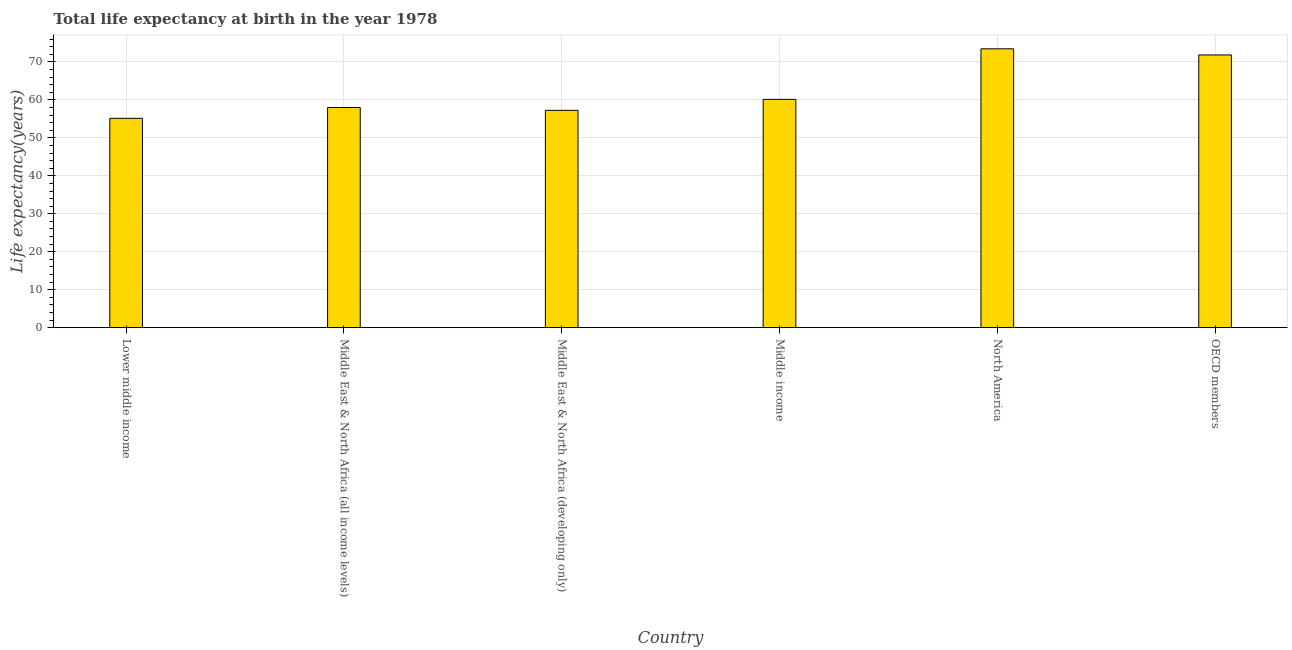Does the graph contain any zero values?
Ensure brevity in your answer.  No. Does the graph contain grids?
Your answer should be very brief. Yes. What is the title of the graph?
Offer a very short reply. Total life expectancy at birth in the year 1978. What is the label or title of the X-axis?
Make the answer very short. Country. What is the label or title of the Y-axis?
Provide a short and direct response. Life expectancy(years). What is the life expectancy at birth in OECD members?
Your answer should be very brief. 71.86. Across all countries, what is the maximum life expectancy at birth?
Make the answer very short. 73.47. Across all countries, what is the minimum life expectancy at birth?
Provide a short and direct response. 55.16. In which country was the life expectancy at birth minimum?
Keep it short and to the point. Lower middle income. What is the sum of the life expectancy at birth?
Give a very brief answer. 375.9. What is the difference between the life expectancy at birth in Lower middle income and Middle East & North Africa (all income levels)?
Your response must be concise. -2.85. What is the average life expectancy at birth per country?
Offer a terse response. 62.65. What is the median life expectancy at birth?
Offer a terse response. 59.08. What is the ratio of the life expectancy at birth in North America to that in OECD members?
Ensure brevity in your answer.  1.02. Is the life expectancy at birth in Middle East & North Africa (developing only) less than that in North America?
Give a very brief answer. Yes. Is the difference between the life expectancy at birth in Middle East & North Africa (developing only) and North America greater than the difference between any two countries?
Provide a succinct answer. No. What is the difference between the highest and the second highest life expectancy at birth?
Keep it short and to the point. 1.61. What is the difference between the highest and the lowest life expectancy at birth?
Make the answer very short. 18.31. How many bars are there?
Provide a succinct answer. 6. Are all the bars in the graph horizontal?
Provide a short and direct response. No. What is the difference between two consecutive major ticks on the Y-axis?
Offer a terse response. 10. Are the values on the major ticks of Y-axis written in scientific E-notation?
Your answer should be compact. No. What is the Life expectancy(years) of Lower middle income?
Your answer should be compact. 55.16. What is the Life expectancy(years) of Middle East & North Africa (all income levels)?
Offer a very short reply. 58. What is the Life expectancy(years) of Middle East & North Africa (developing only)?
Make the answer very short. 57.26. What is the Life expectancy(years) in Middle income?
Give a very brief answer. 60.15. What is the Life expectancy(years) of North America?
Provide a short and direct response. 73.47. What is the Life expectancy(years) in OECD members?
Make the answer very short. 71.86. What is the difference between the Life expectancy(years) in Lower middle income and Middle East & North Africa (all income levels)?
Give a very brief answer. -2.85. What is the difference between the Life expectancy(years) in Lower middle income and Middle East & North Africa (developing only)?
Provide a succinct answer. -2.1. What is the difference between the Life expectancy(years) in Lower middle income and Middle income?
Your answer should be compact. -5. What is the difference between the Life expectancy(years) in Lower middle income and North America?
Offer a very short reply. -18.31. What is the difference between the Life expectancy(years) in Lower middle income and OECD members?
Ensure brevity in your answer.  -16.7. What is the difference between the Life expectancy(years) in Middle East & North Africa (all income levels) and Middle East & North Africa (developing only)?
Provide a succinct answer. 0.74. What is the difference between the Life expectancy(years) in Middle East & North Africa (all income levels) and Middle income?
Provide a succinct answer. -2.15. What is the difference between the Life expectancy(years) in Middle East & North Africa (all income levels) and North America?
Provide a short and direct response. -15.47. What is the difference between the Life expectancy(years) in Middle East & North Africa (all income levels) and OECD members?
Provide a short and direct response. -13.85. What is the difference between the Life expectancy(years) in Middle East & North Africa (developing only) and Middle income?
Ensure brevity in your answer.  -2.89. What is the difference between the Life expectancy(years) in Middle East & North Africa (developing only) and North America?
Provide a short and direct response. -16.21. What is the difference between the Life expectancy(years) in Middle East & North Africa (developing only) and OECD members?
Give a very brief answer. -14.59. What is the difference between the Life expectancy(years) in Middle income and North America?
Make the answer very short. -13.32. What is the difference between the Life expectancy(years) in Middle income and OECD members?
Offer a very short reply. -11.7. What is the difference between the Life expectancy(years) in North America and OECD members?
Provide a succinct answer. 1.62. What is the ratio of the Life expectancy(years) in Lower middle income to that in Middle East & North Africa (all income levels)?
Ensure brevity in your answer.  0.95. What is the ratio of the Life expectancy(years) in Lower middle income to that in Middle income?
Offer a terse response. 0.92. What is the ratio of the Life expectancy(years) in Lower middle income to that in North America?
Your response must be concise. 0.75. What is the ratio of the Life expectancy(years) in Lower middle income to that in OECD members?
Offer a very short reply. 0.77. What is the ratio of the Life expectancy(years) in Middle East & North Africa (all income levels) to that in Middle East & North Africa (developing only)?
Make the answer very short. 1.01. What is the ratio of the Life expectancy(years) in Middle East & North Africa (all income levels) to that in Middle income?
Provide a short and direct response. 0.96. What is the ratio of the Life expectancy(years) in Middle East & North Africa (all income levels) to that in North America?
Ensure brevity in your answer.  0.79. What is the ratio of the Life expectancy(years) in Middle East & North Africa (all income levels) to that in OECD members?
Your answer should be very brief. 0.81. What is the ratio of the Life expectancy(years) in Middle East & North Africa (developing only) to that in North America?
Keep it short and to the point. 0.78. What is the ratio of the Life expectancy(years) in Middle East & North Africa (developing only) to that in OECD members?
Provide a succinct answer. 0.8. What is the ratio of the Life expectancy(years) in Middle income to that in North America?
Offer a very short reply. 0.82. What is the ratio of the Life expectancy(years) in Middle income to that in OECD members?
Offer a terse response. 0.84. 